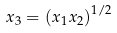Convert formula to latex. <formula><loc_0><loc_0><loc_500><loc_500>x _ { 3 } = \left ( x _ { 1 } x _ { 2 } \right ) ^ { 1 / 2 }</formula> 